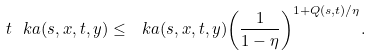<formula> <loc_0><loc_0><loc_500><loc_500>\ t { \ k a } ( s , x , t , y ) \leq \ k a ( s , x , t , y ) { \left ( \frac { 1 } { 1 - \eta } \right ) } ^ { 1 + Q ( s , t ) / \eta } .</formula> 